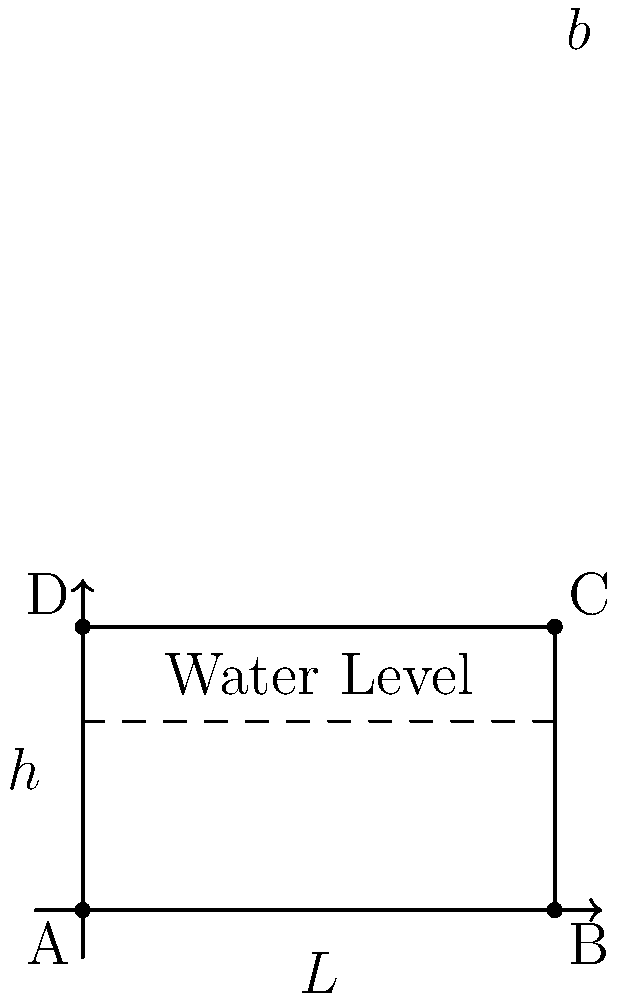You're designing a dam for a new water reservoir near your kids' favorite camping spot. The dam needs to hold $10,000,000$ m³ of water. If the length of the dam ($L$) is $500$ m and the width ($b$) is $20$ m, what should be the height ($h$) of the dam in meters? Assume the dam is rectangular and the terrain behind it forms a perfect triangle. Let's approach this step-by-step:

1) The volume of water behind a triangular dam is given by the formula:

   $$V = \frac{1}{2} \times L \times h \times b$$

   Where:
   $V$ = Volume of water
   $L$ = Length of the dam
   $h$ = Height of the dam
   $b$ = Width of the dam

2) We know:
   $V = 10,000,000$ m³
   $L = 500$ m
   $b = 20$ m

3) Let's substitute these values into our formula:

   $$10,000,000 = \frac{1}{2} \times 500 \times h \times 20$$

4) Simplify:

   $$10,000,000 = 5000h$$

5) Solve for $h$:

   $$h = \frac{10,000,000}{5000} = 2000$$

Therefore, the height of the dam should be 2000 meters.
Answer: 2000 m 